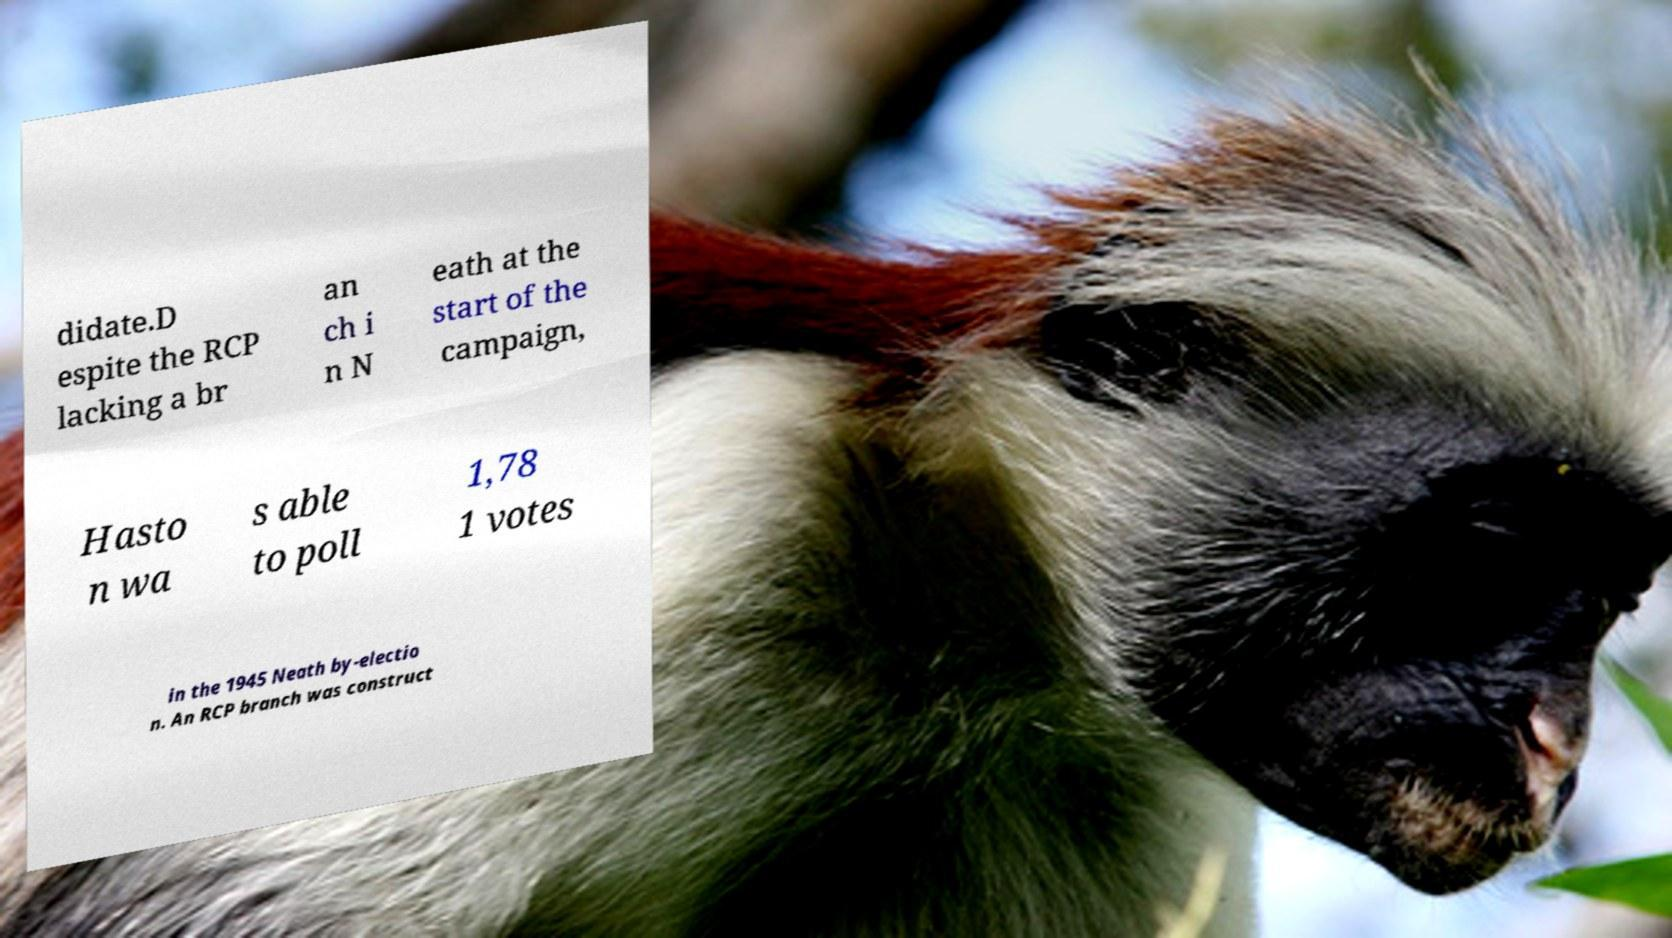For documentation purposes, I need the text within this image transcribed. Could you provide that? didate.D espite the RCP lacking a br an ch i n N eath at the start of the campaign, Hasto n wa s able to poll 1,78 1 votes in the 1945 Neath by-electio n. An RCP branch was construct 